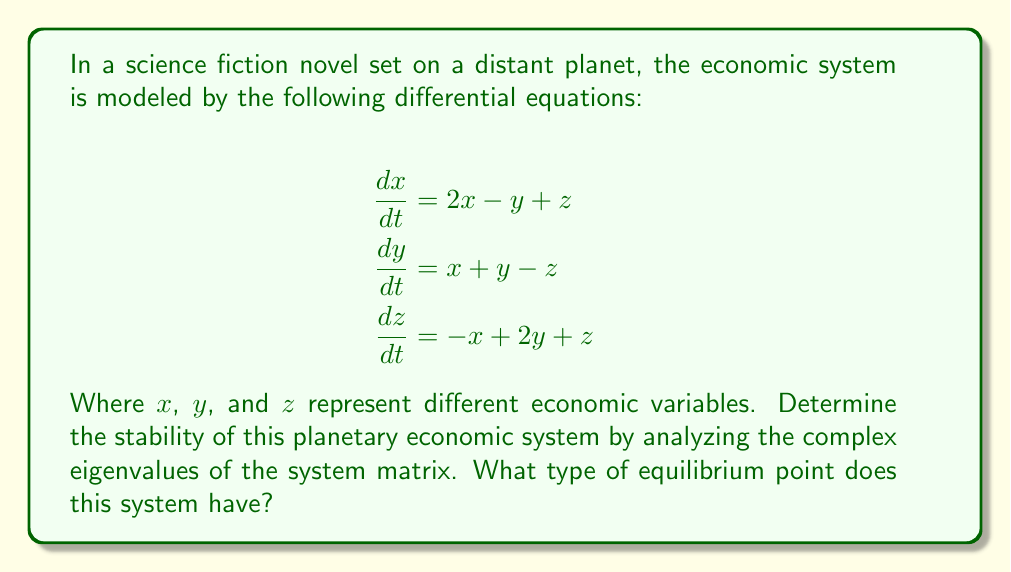What is the answer to this math problem? To analyze the stability of the system, we need to follow these steps:

1) First, we need to write the system matrix $A$:

   $$A = \begin{bmatrix}
   2 & -1 & 1 \\
   1 & 1 & -1 \\
   -1 & 2 & 1
   \end{bmatrix}$$

2) Calculate the characteristic equation:
   $$det(A - \lambda I) = 0$$
   
   $$(2-\lambda)((1-\lambda)(1-\lambda) - (-1)(2)) - (-1)(1(1-\lambda) - (-1)(-1)) + 1(1(-1) - (1-\lambda)(2)) = 0$$

3) Simplify:
   $$-\lambda^3 + 4\lambda^2 - \lambda - 6 = 0$$

4) Solve for the eigenvalues. This cubic equation can be factored as:
   $$(\lambda - 3)(\lambda - 1 + i)(\lambda - 1 - i) = 0$$

   So, the eigenvalues are:
   $$\lambda_1 = 3, \lambda_2 = 1 + i, \lambda_3 = 1 - i$$

5) Analyze the eigenvalues:
   - $\lambda_1 = 3$ is a real, positive eigenvalue
   - $\lambda_2$ and $\lambda_3$ are complex conjugates with positive real parts

6) Interpret the results:
   - The presence of a positive real eigenvalue ($\lambda_1 = 3$) indicates exponential growth in one direction.
   - The complex conjugate pair with positive real parts ($\lambda_2$ and $\lambda_3$) indicates spiraling outward in a plane.

Therefore, this system has an unstable equilibrium point, specifically an unstable spiral node (or unstable focus).
Answer: Unstable spiral node (unstable focus) 